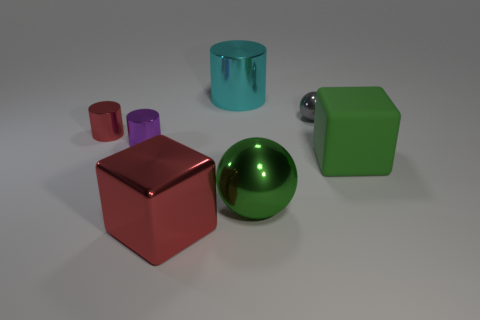Add 2 big red cylinders. How many objects exist? 9 Subtract all cylinders. How many objects are left? 4 Subtract all gray balls. Subtract all metallic things. How many objects are left? 0 Add 7 tiny things. How many tiny things are left? 10 Add 3 tiny gray things. How many tiny gray things exist? 4 Subtract 1 cyan cylinders. How many objects are left? 6 